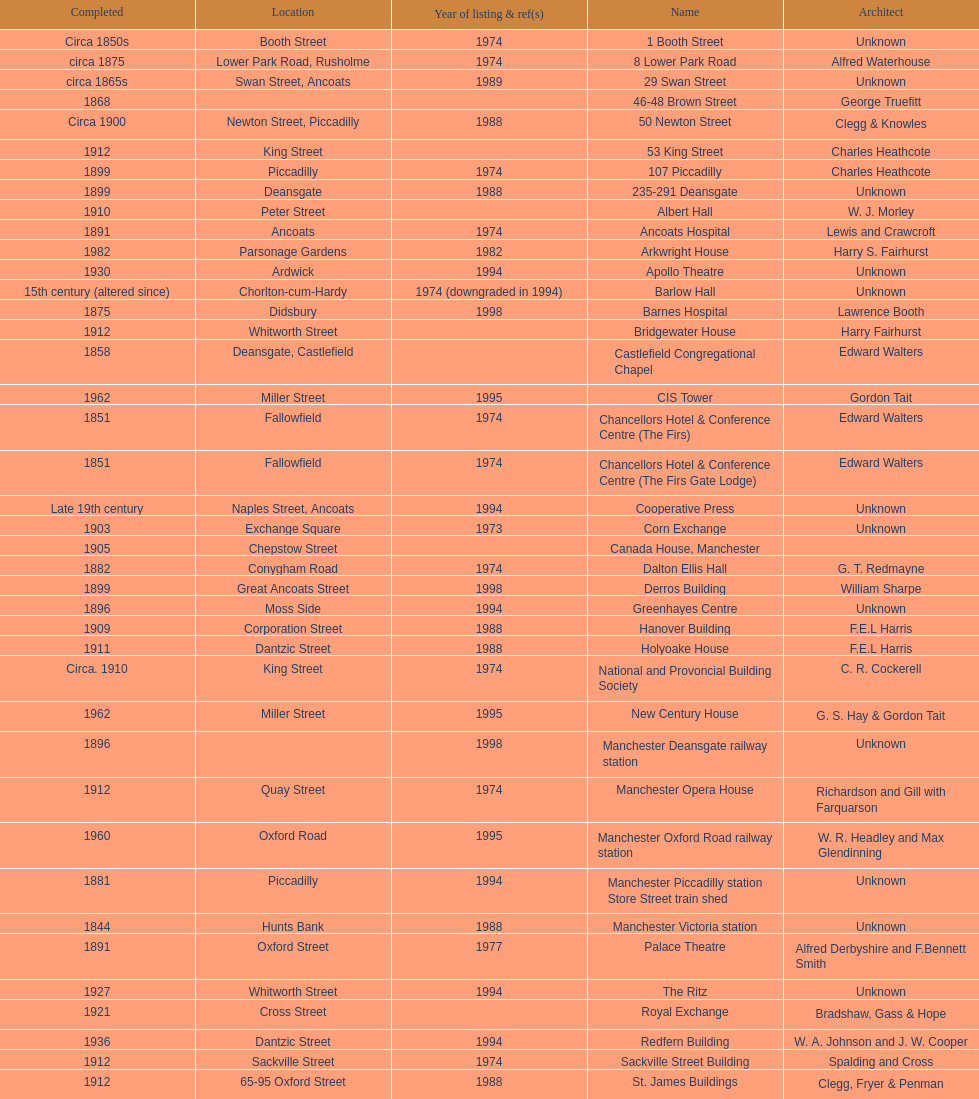How many names are listed with an image? 39. 